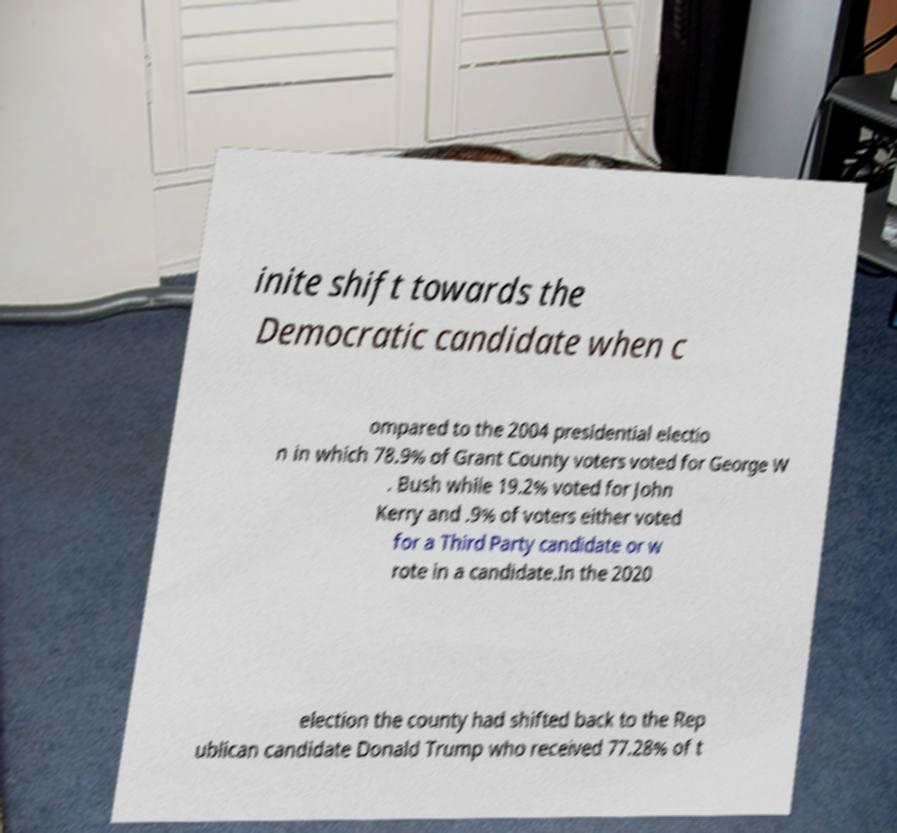What messages or text are displayed in this image? I need them in a readable, typed format. inite shift towards the Democratic candidate when c ompared to the 2004 presidential electio n in which 78.9% of Grant County voters voted for George W . Bush while 19.2% voted for John Kerry and .9% of voters either voted for a Third Party candidate or w rote in a candidate.In the 2020 election the county had shifted back to the Rep ublican candidate Donald Trump who received 77.28% of t 